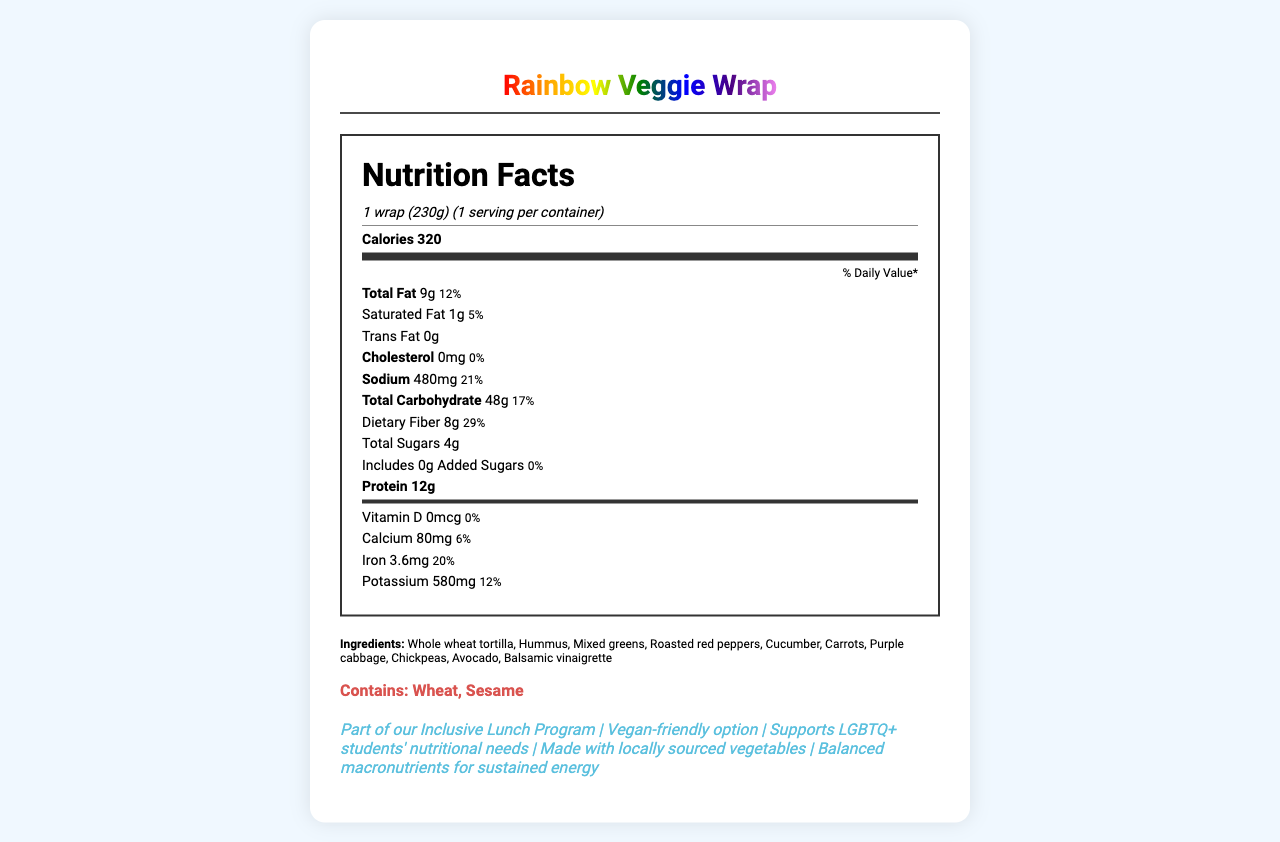what is the serving size of the Rainbow Veggie Wrap? The serving size is mentioned at the top of the nutrition facts section as "1 wrap (230g)".
Answer: 1 wrap (230g) how many calories does the Rainbow Veggie Wrap contain? The calories are listed near the top of the nutrition facts section as "Calories 320".
Answer: 320 what is the total amount of fat in the Rainbow Veggie Wrap? The total fat content is specified as "Total Fat 9g".
Answer: 9g what percentage of the daily value does the sodium content represent? The sodium content percentage is listed as "Sodium 480mg 21%".
Answer: 21% how much dietary fiber is in the Rainbow Veggie Wrap? The dietary fiber content is mentioned as "Dietary Fiber 8g".
Answer: 8g how much protein does the Rainbow Veggie Wrap provide? The amount of protein is specified as "Protein 12g".
Answer: 12g which of the following allergens does the Rainbow Veggie Wrap contain? A. Dairy B. Soy C. Wheat D. Nuts The document lists "Contains: Wheat, Sesame" in the allergens section.
Answer: C. Wheat how many grams of added sugars are in the Rainbow Veggie Wrap? A. 2g B. 4g C. 6g D. 0g The added sugars are specified as "Includes 0g Added Sugars".
Answer: D. 0g does the Rainbow Veggie Wrap contain any cholesterol? The section for cholesterol states "Cholesterol 0mg," indicating no cholesterol.
Answer: No does the Rainbow Veggie Wrap support LGBTQ+ students' nutritional needs? The additional information section includes "Supports LGBTQ+ students' nutritional needs".
Answer: Yes what is the Daily Value percentage of Vitamin D in the Rainbow Veggie Wrap? The document lists "Vitamin D 0mcg 0%" indicating no contribution to the daily value of Vitamin D.
Answer: 0% what initiative is the Rainbow Veggie Wrap part of? The additional information mentions "Part of our Inclusive Lunch Program".
Answer: Inclusive Lunch Program can you determine the specific quantity of each ingredient in the Rainbow Veggie Wrap from the document? The document lists the ingredients but does not specify the quantity of each ingredient.
Answer: Cannot be determined 